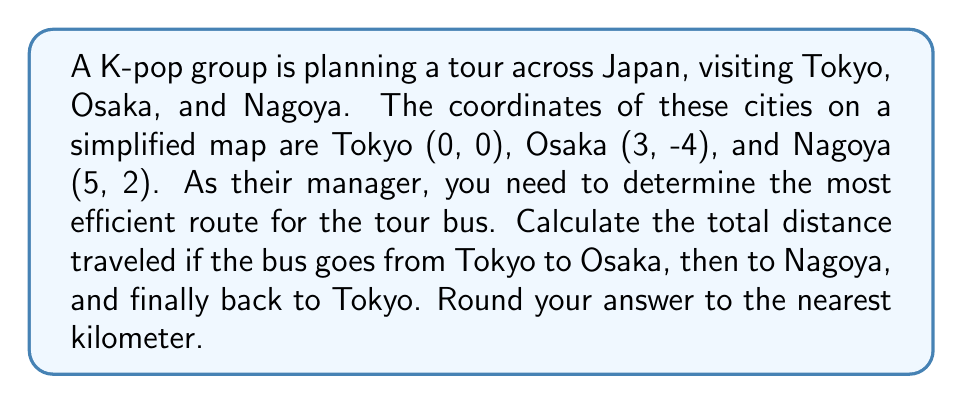Provide a solution to this math problem. To solve this problem, we'll use the distance formula between two points:
$$d = \sqrt{(x_2 - x_1)^2 + (y_2 - y_1)^2}$$

Step 1: Calculate the distance from Tokyo to Osaka
Tokyo (0, 0) to Osaka (3, -4)
$$d_{TO} = \sqrt{(3 - 0)^2 + (-4 - 0)^2} = \sqrt{9 + 16} = \sqrt{25} = 5$$

Step 2: Calculate the distance from Osaka to Nagoya
Osaka (3, -4) to Nagoya (5, 2)
$$d_{ON} = \sqrt{(5 - 3)^2 + (2 - (-4))^2} = \sqrt{4 + 36} = \sqrt{40} = 2\sqrt{10} \approx 6.32$$

Step 3: Calculate the distance from Nagoya back to Tokyo
Nagoya (5, 2) to Tokyo (0, 0)
$$d_{NT} = \sqrt{(0 - 5)^2 + (0 - 2)^2} = \sqrt{25 + 4} = \sqrt{29} \approx 5.39$$

Step 4: Sum up all distances
Total distance = $d_{TO} + d_{ON} + d_{NT}$
$$5 + 6.32 + 5.39 = 16.71$$

Step 5: Round to the nearest kilometer
16.71 rounds to 17 km
Answer: 17 km 